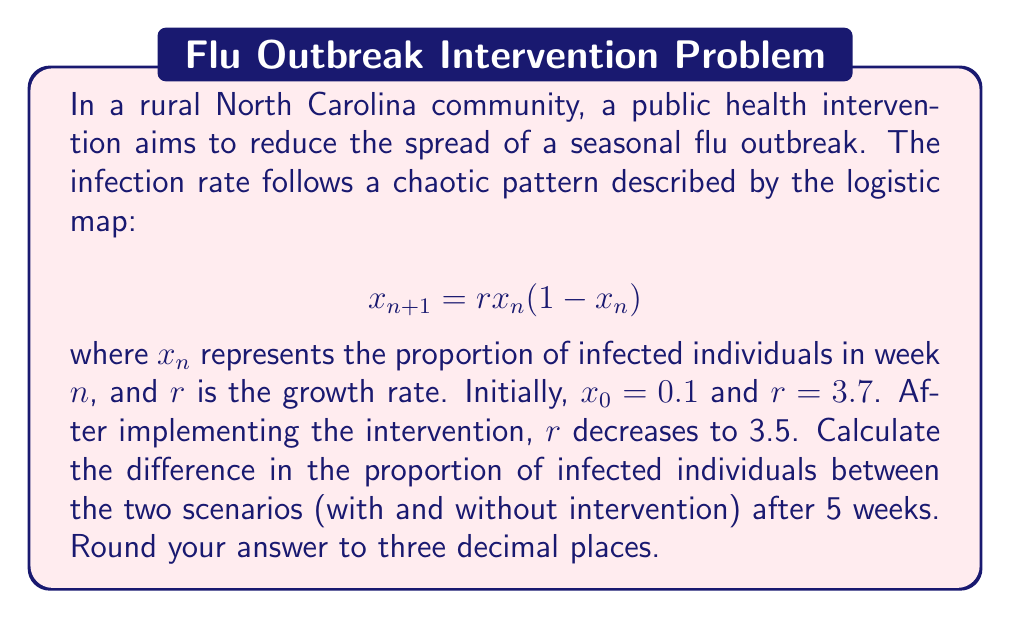Solve this math problem. To solve this problem, we need to iterate the logistic map for both scenarios and compare the results after 5 weeks.

Scenario 1 (Without intervention, $r = 3.7$):
1. $x_1 = 3.7 * 0.1 * (1 - 0.1) = 0.333$
2. $x_2 = 3.7 * 0.333 * (1 - 0.333) = 0.824$
3. $x_3 = 3.7 * 0.824 * (1 - 0.824) = 0.537$
4. $x_4 = 3.7 * 0.537 * (1 - 0.537) = 0.920$
5. $x_5 = 3.7 * 0.920 * (1 - 0.920) = 0.272$

Scenario 2 (With intervention, $r = 3.5$):
1. $x_1 = 3.5 * 0.1 * (1 - 0.1) = 0.315$
2. $x_2 = 3.5 * 0.315 * (1 - 0.315) = 0.756$
3. $x_3 = 3.5 * 0.756 * (1 - 0.756) = 0.646$
4. $x_4 = 3.5 * 0.646 * (1 - 0.646) = 0.802$
5. $x_5 = 3.5 * 0.802 * (1 - 0.802) = 0.557$

The difference in the proportion of infected individuals after 5 weeks is:
$|0.272 - 0.557| = 0.285$

Rounding to three decimal places: 0.285
Answer: 0.285 